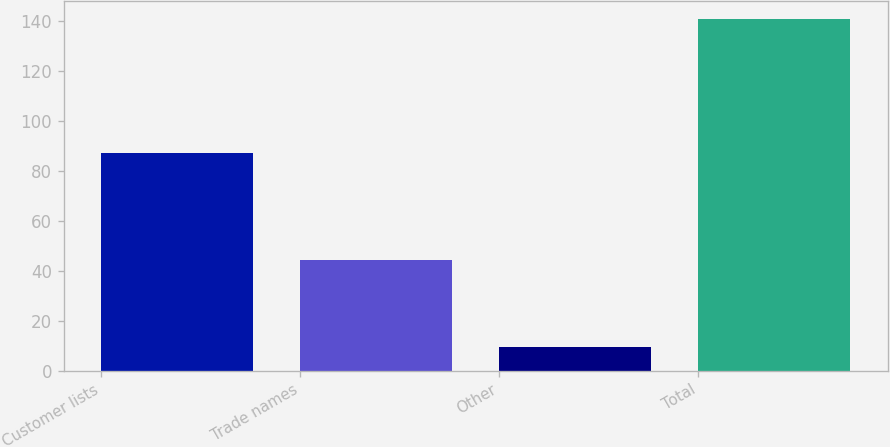Convert chart to OTSL. <chart><loc_0><loc_0><loc_500><loc_500><bar_chart><fcel>Customer lists<fcel>Trade names<fcel>Other<fcel>Total<nl><fcel>87.1<fcel>44.2<fcel>9.4<fcel>140.7<nl></chart> 